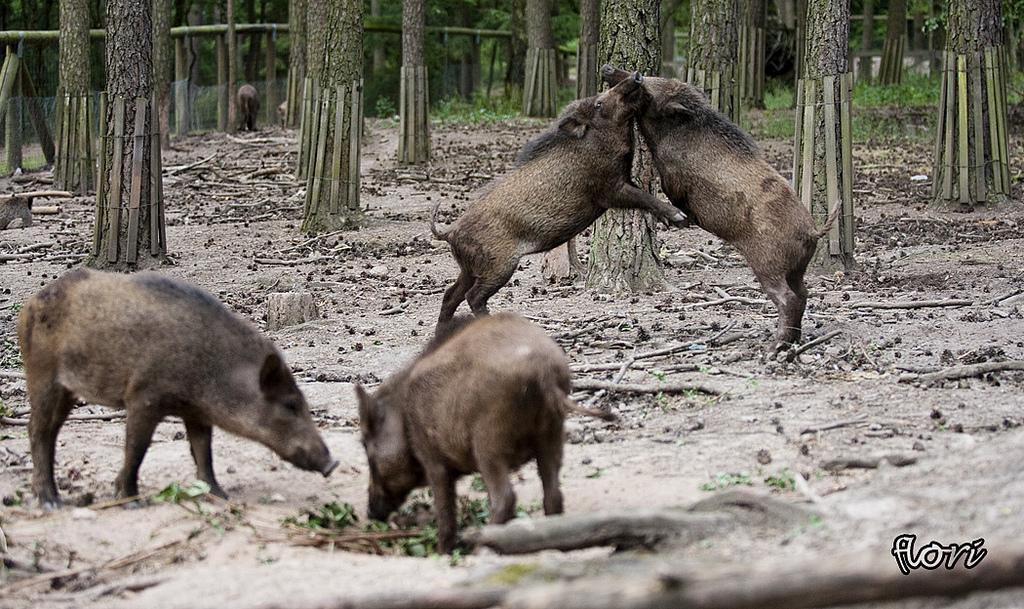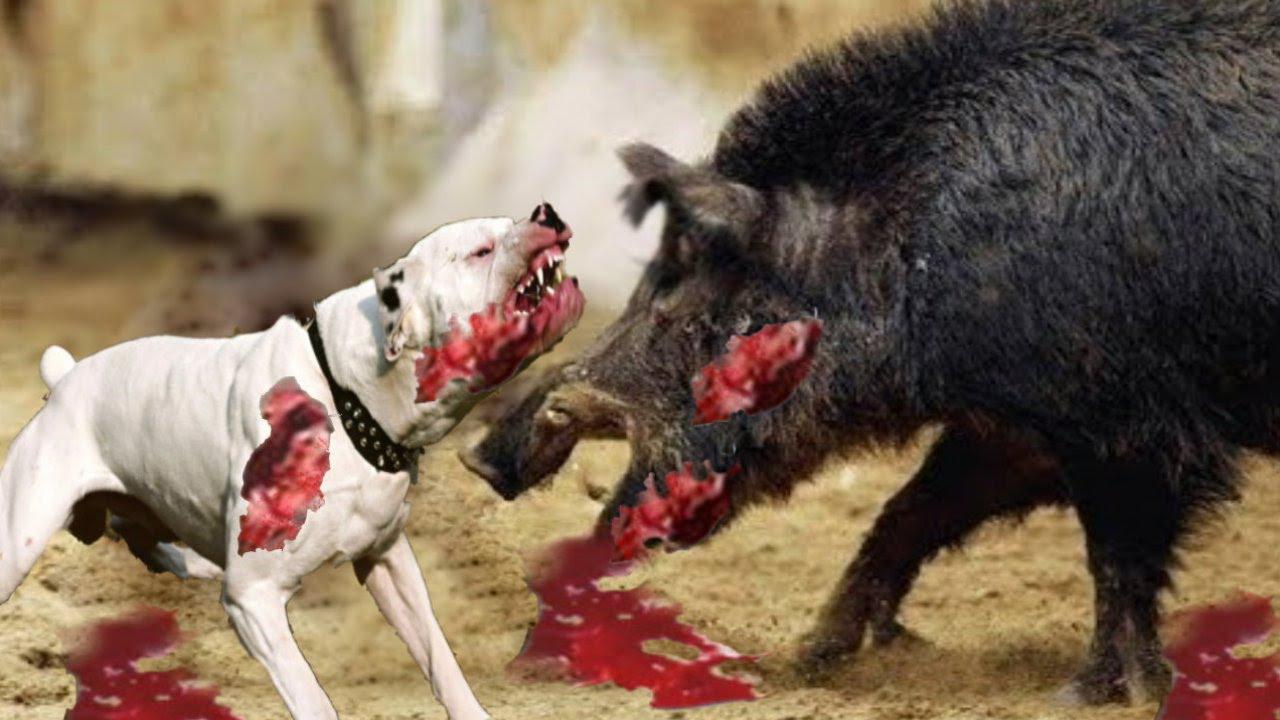The first image is the image on the left, the second image is the image on the right. For the images shown, is this caption "There is a single animal in the right image." true? Answer yes or no. No. 